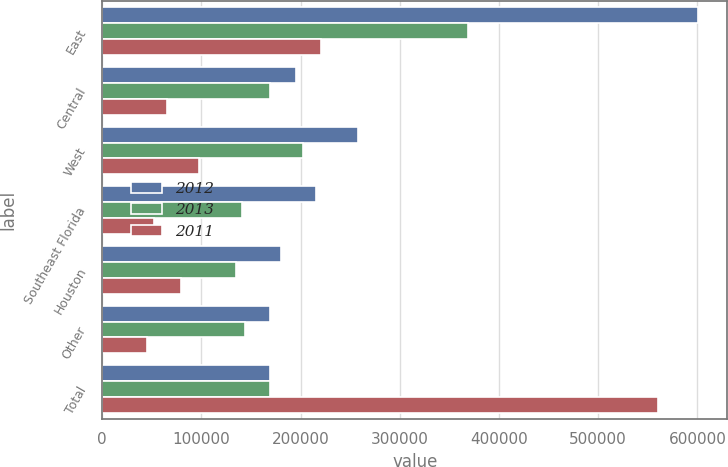Convert chart. <chart><loc_0><loc_0><loc_500><loc_500><stacked_bar_chart><ecel><fcel>East<fcel>Central<fcel>West<fcel>Southeast Florida<fcel>Houston<fcel>Other<fcel>Total<nl><fcel>2012<fcel>600257<fcel>195762<fcel>257498<fcel>215988<fcel>180665<fcel>169431<fcel>169431<nl><fcel>2013<fcel>368361<fcel>168912<fcel>202959<fcel>141146<fcel>135282<fcel>143725<fcel>169431<nl><fcel>2011<fcel>220974<fcel>65256<fcel>97292<fcel>52013<fcel>79800<fcel>45324<fcel>560659<nl></chart> 